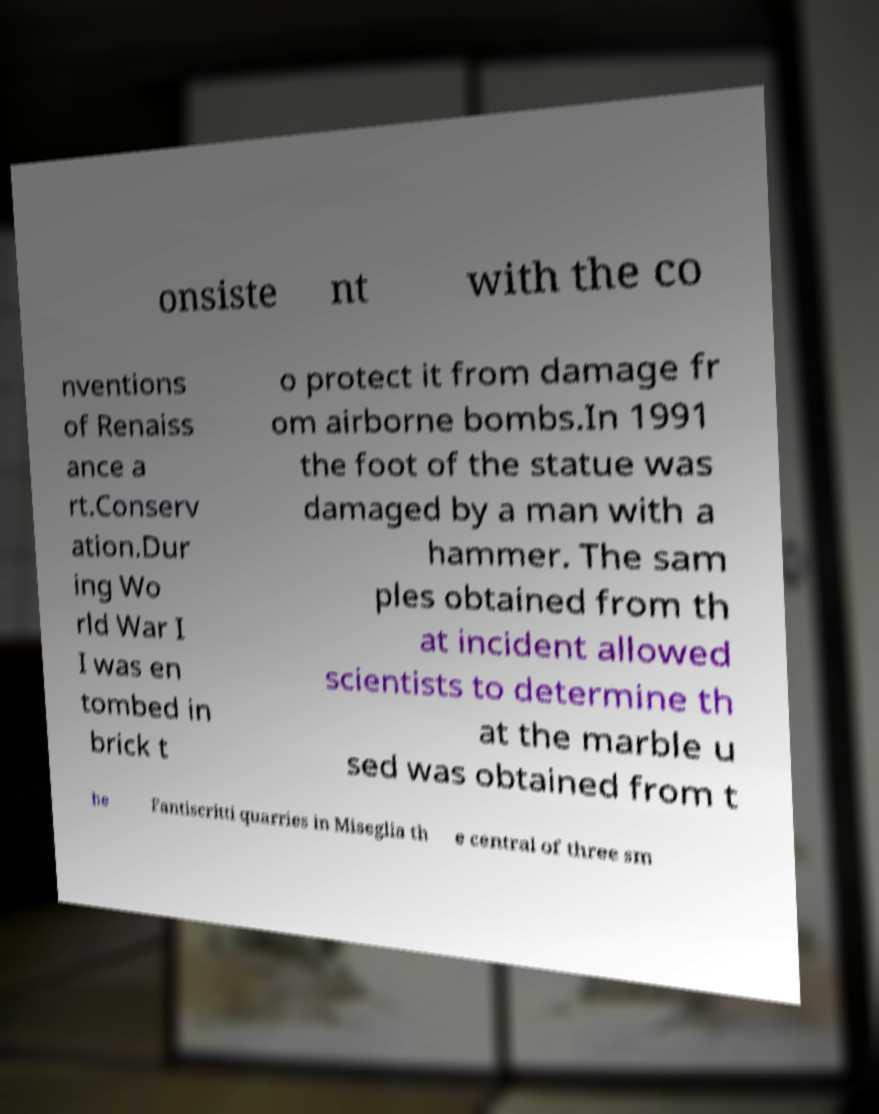Can you accurately transcribe the text from the provided image for me? onsiste nt with the co nventions of Renaiss ance a rt.Conserv ation.Dur ing Wo rld War I I was en tombed in brick t o protect it from damage fr om airborne bombs.In 1991 the foot of the statue was damaged by a man with a hammer. The sam ples obtained from th at incident allowed scientists to determine th at the marble u sed was obtained from t he Fantiscritti quarries in Miseglia th e central of three sm 